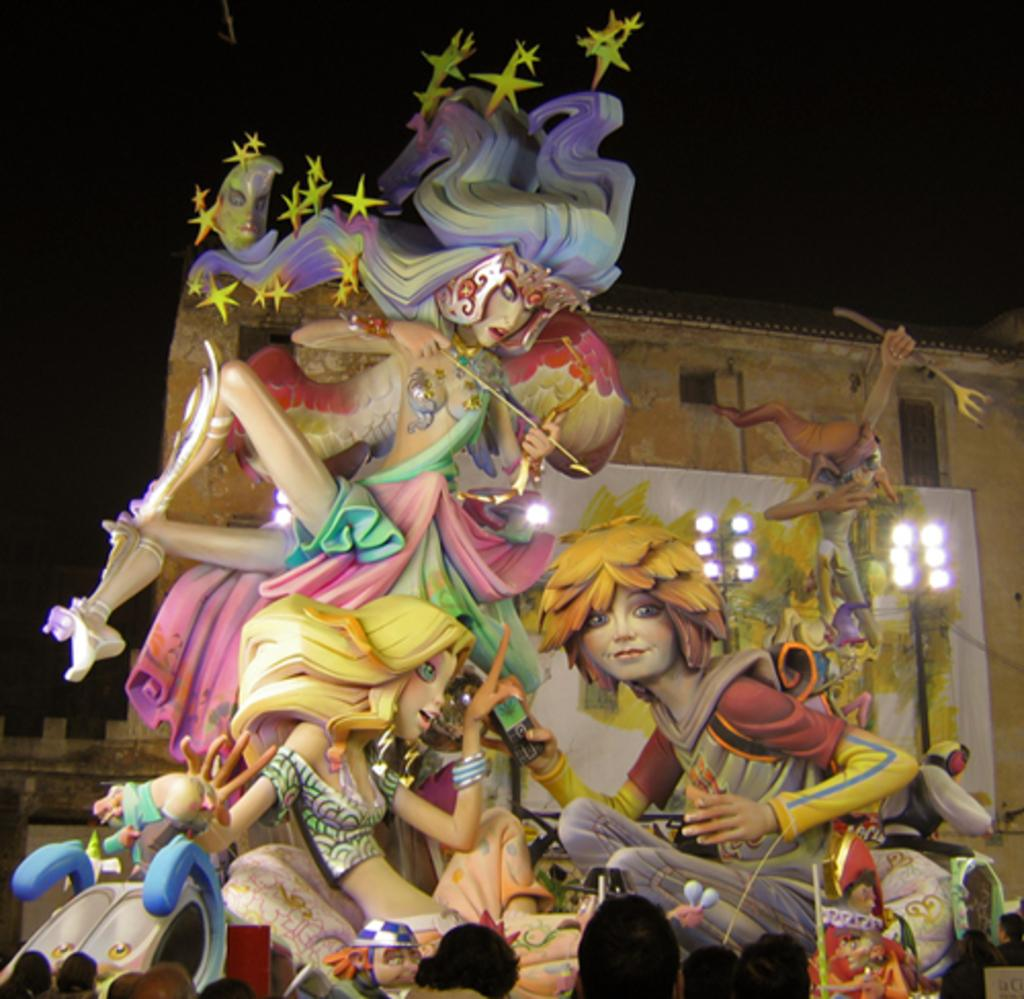What objects can be seen in the image related to work or organization? There are files in the image. What natural feature is present in the image? There is a waterfall in the image. What structure is located behind the waterfall? There is a building behind the waterfall. What type of lighting is present in the image? There are poles with lights in the image. How would you describe the background behind the building? The background behind the building is dark. How many chairs are placed around the waterfall in the image? There are no chairs present in the image; it features a waterfall, a building, and poles with lights. What type of cable can be seen connecting the waterfall to the building? There is no cable connecting the waterfall to the building in the image. 